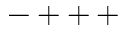<formula> <loc_0><loc_0><loc_500><loc_500>- + + \, +</formula> 